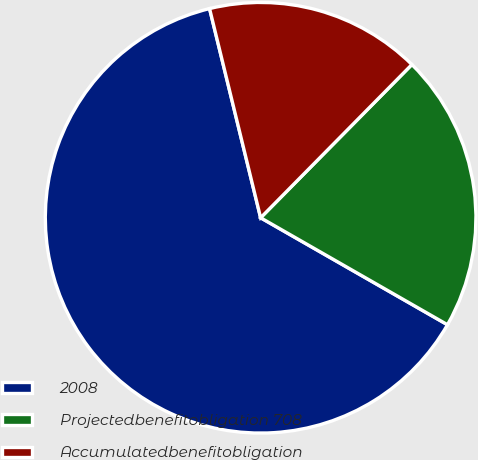Convert chart to OTSL. <chart><loc_0><loc_0><loc_500><loc_500><pie_chart><fcel>2008<fcel>Projectedbenefitobligation 708<fcel>Accumulatedbenefitobligation<nl><fcel>62.92%<fcel>20.88%<fcel>16.21%<nl></chart> 